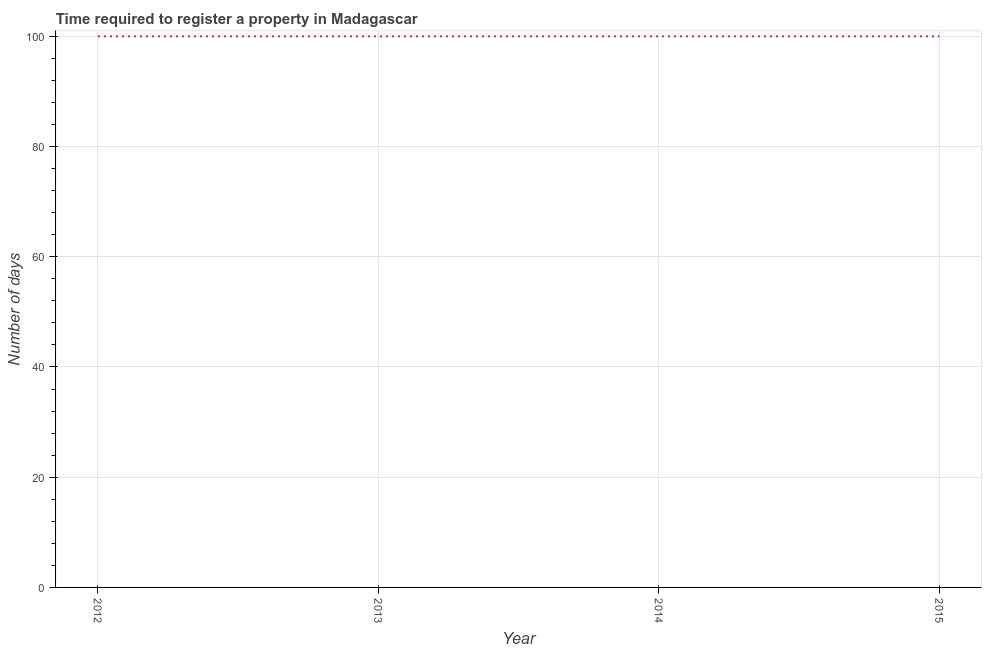What is the number of days required to register property in 2015?
Provide a short and direct response. 100. Across all years, what is the maximum number of days required to register property?
Keep it short and to the point. 100. Across all years, what is the minimum number of days required to register property?
Your answer should be compact. 100. In which year was the number of days required to register property maximum?
Provide a short and direct response. 2012. In which year was the number of days required to register property minimum?
Provide a short and direct response. 2012. What is the sum of the number of days required to register property?
Offer a terse response. 400. What is the average number of days required to register property per year?
Your answer should be compact. 100. What is the median number of days required to register property?
Your answer should be compact. 100. In how many years, is the number of days required to register property greater than 52 days?
Your response must be concise. 4. Is the difference between the number of days required to register property in 2014 and 2015 greater than the difference between any two years?
Your response must be concise. Yes. Is the sum of the number of days required to register property in 2013 and 2014 greater than the maximum number of days required to register property across all years?
Provide a short and direct response. Yes. In how many years, is the number of days required to register property greater than the average number of days required to register property taken over all years?
Your answer should be very brief. 0. How many lines are there?
Offer a terse response. 1. Are the values on the major ticks of Y-axis written in scientific E-notation?
Offer a terse response. No. Does the graph contain any zero values?
Give a very brief answer. No. Does the graph contain grids?
Your answer should be compact. Yes. What is the title of the graph?
Ensure brevity in your answer.  Time required to register a property in Madagascar. What is the label or title of the X-axis?
Your answer should be compact. Year. What is the label or title of the Y-axis?
Your answer should be compact. Number of days. What is the Number of days in 2012?
Offer a very short reply. 100. What is the Number of days in 2013?
Your response must be concise. 100. What is the difference between the Number of days in 2012 and 2013?
Ensure brevity in your answer.  0. What is the difference between the Number of days in 2012 and 2015?
Give a very brief answer. 0. What is the ratio of the Number of days in 2012 to that in 2013?
Your answer should be very brief. 1. 